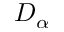Convert formula to latex. <formula><loc_0><loc_0><loc_500><loc_500>D _ { \alpha }</formula> 